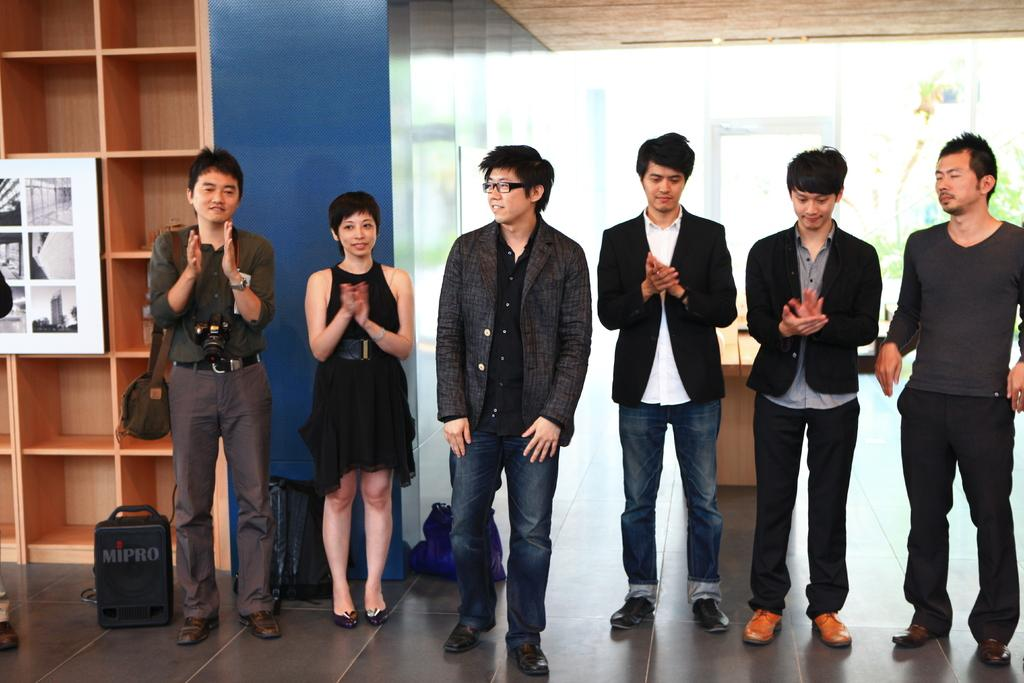What can be seen in the image involving people? There are people standing in the image. Where are the people standing? The people are standing on the floor. What else is present in the image besides people? There are bags, wooden racks, and a poster in the image. How many units of sofa are visible in the image? There is no sofa present in the image. What is the amount of water in the image? There is no reference to water in the image, so it cannot be determined how much water is present. 